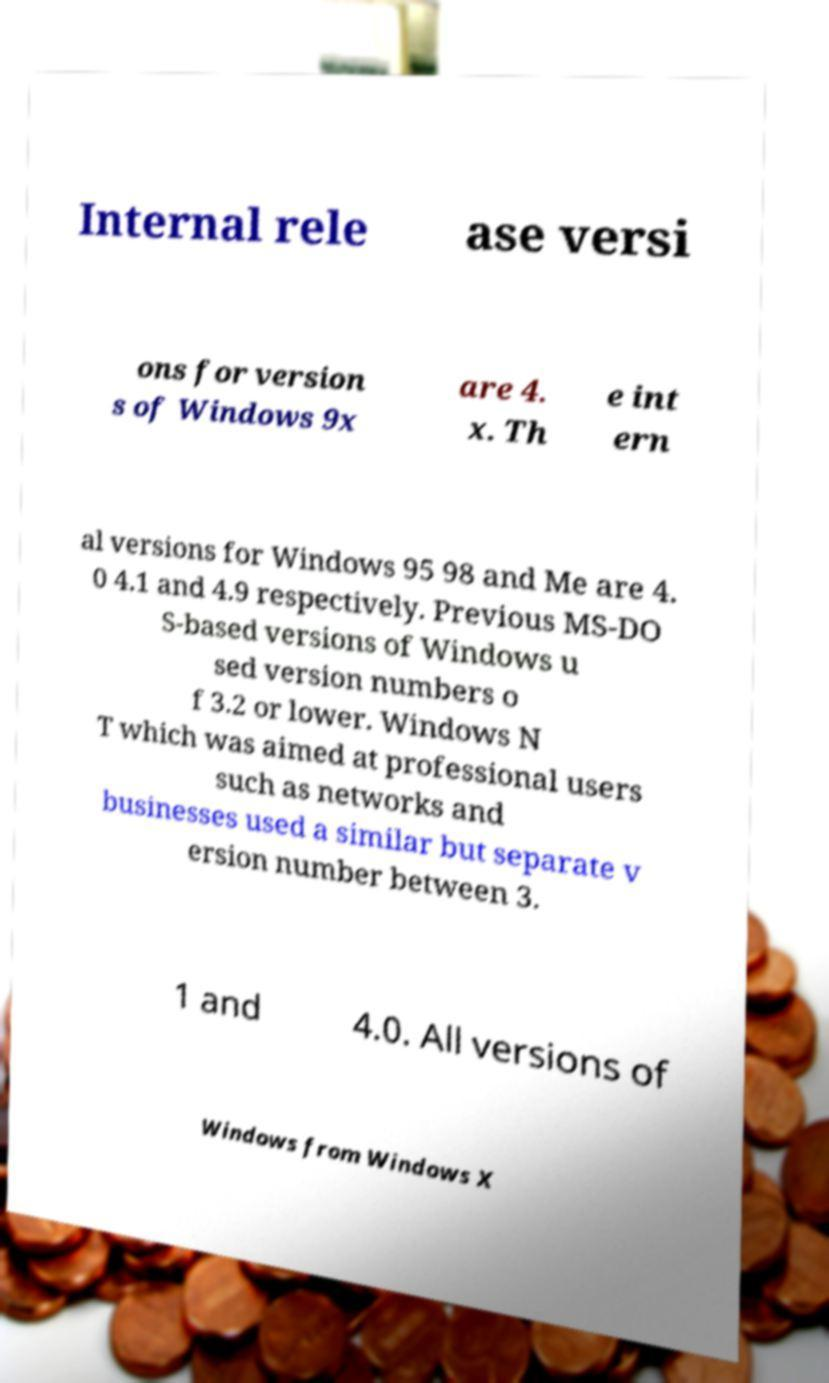Can you accurately transcribe the text from the provided image for me? Internal rele ase versi ons for version s of Windows 9x are 4. x. Th e int ern al versions for Windows 95 98 and Me are 4. 0 4.1 and 4.9 respectively. Previous MS-DO S-based versions of Windows u sed version numbers o f 3.2 or lower. Windows N T which was aimed at professional users such as networks and businesses used a similar but separate v ersion number between 3. 1 and 4.0. All versions of Windows from Windows X 